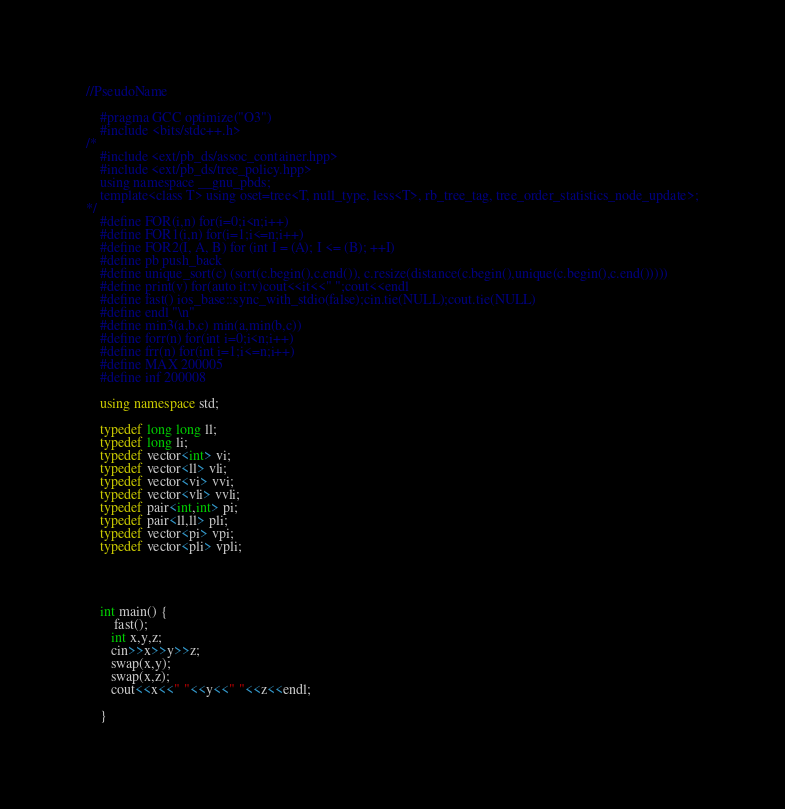Convert code to text. <code><loc_0><loc_0><loc_500><loc_500><_C++_>//PseudoName

    #pragma GCC optimize("O3")
    #include <bits/stdc++.h>
/*
	#include <ext/pb_ds/assoc_container.hpp>
	#include <ext/pb_ds/tree_policy.hpp>
	using namespace __gnu_pbds;
	template<class T> using oset=tree<T, null_type, less<T>, rb_tree_tag, tree_order_statistics_node_update>;
*/
    #define FOR(i,n) for(i=0;i<n;i++)
    #define FOR1(i,n) for(i=1;i<=n;i++)
    #define FOR2(I, A, B) for (int I = (A); I <= (B); ++I)
    #define pb push_back
    #define unique_sort(c) (sort(c.begin(),c.end()), c.resize(distance(c.begin(),unique(c.begin(),c.end()))))
    #define print(v) for(auto it:v)cout<<it<<" ";cout<<endl
    #define fast() ios_base::sync_with_stdio(false);cin.tie(NULL);cout.tie(NULL)
    #define endl "\n"
    #define min3(a,b,c) min(a,min(b,c))
    #define forr(n) for(int i=0;i<n;i++)
    #define frr(n) for(int i=1;i<=n;i++)
    #define MAX 200005
    #define inf 200008

    using namespace std;

    typedef long long ll;
    typedef long li;
    typedef vector<int> vi;
    typedef vector<ll> vli;
    typedef vector<vi> vvi;
    typedef vector<vli> vvli;
    typedef pair<int,int> pi;
    typedef pair<ll,ll> pli;
    typedef vector<pi> vpi;
    typedef vector<pli> vpli;




    int main() {
        fast();
       int x,y,z;
       cin>>x>>y>>z;
       swap(x,y);
       swap(x,z);
       cout<<x<<" "<<y<<" "<<z<<endl;

    }
</code> 